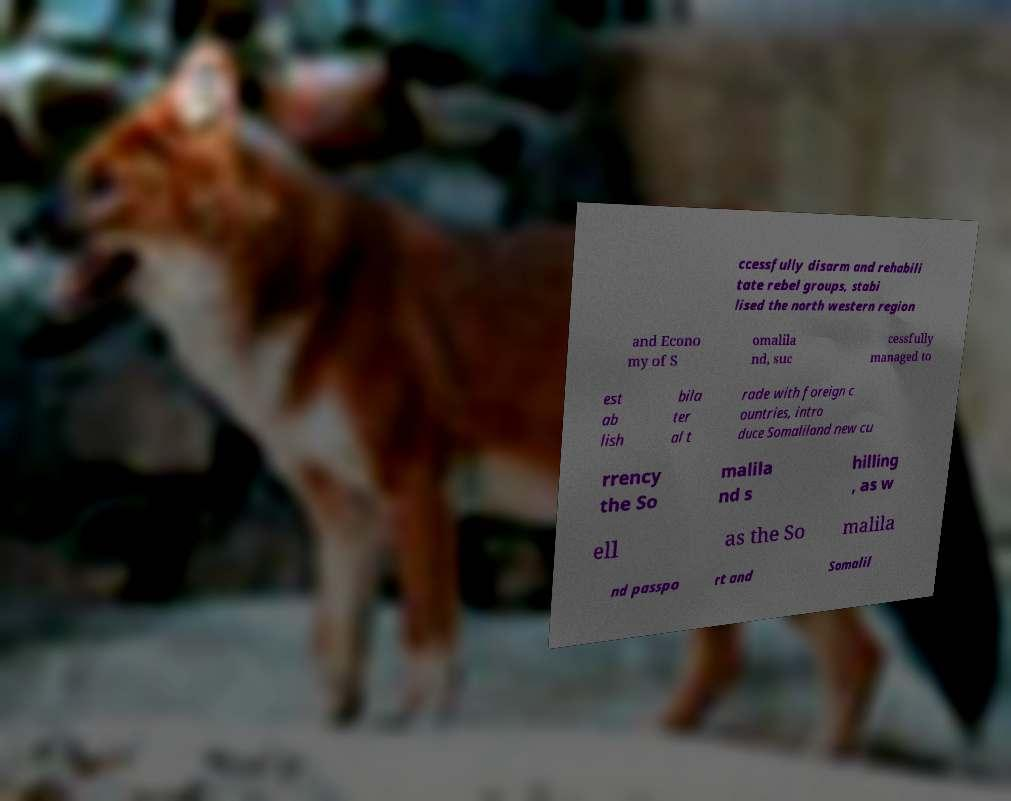What messages or text are displayed in this image? I need them in a readable, typed format. ccessfully disarm and rehabili tate rebel groups, stabi lised the north western region and Econo my of S omalila nd, suc cessfully managed to est ab lish bila ter al t rade with foreign c ountries, intro duce Somaliland new cu rrency the So malila nd s hilling , as w ell as the So malila nd passpo rt and Somalil 